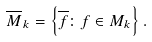Convert formula to latex. <formula><loc_0><loc_0><loc_500><loc_500>\overline { M } _ { k } = \left \{ \overline { f } \colon f \in M _ { k } \right \} .</formula> 